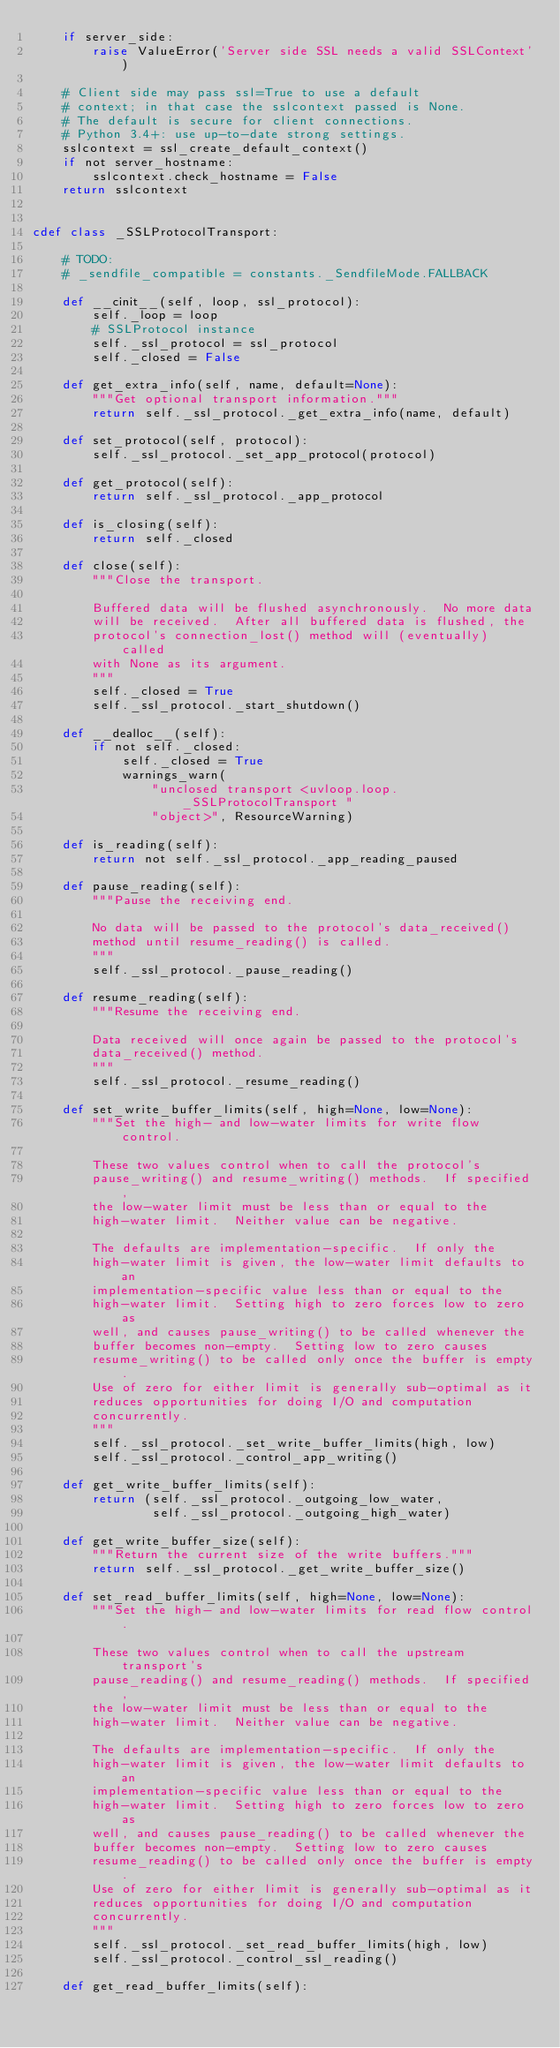Convert code to text. <code><loc_0><loc_0><loc_500><loc_500><_Cython_>    if server_side:
        raise ValueError('Server side SSL needs a valid SSLContext')

    # Client side may pass ssl=True to use a default
    # context; in that case the sslcontext passed is None.
    # The default is secure for client connections.
    # Python 3.4+: use up-to-date strong settings.
    sslcontext = ssl_create_default_context()
    if not server_hostname:
        sslcontext.check_hostname = False
    return sslcontext


cdef class _SSLProtocolTransport:

    # TODO:
    # _sendfile_compatible = constants._SendfileMode.FALLBACK

    def __cinit__(self, loop, ssl_protocol):
        self._loop = loop
        # SSLProtocol instance
        self._ssl_protocol = ssl_protocol
        self._closed = False

    def get_extra_info(self, name, default=None):
        """Get optional transport information."""
        return self._ssl_protocol._get_extra_info(name, default)

    def set_protocol(self, protocol):
        self._ssl_protocol._set_app_protocol(protocol)

    def get_protocol(self):
        return self._ssl_protocol._app_protocol

    def is_closing(self):
        return self._closed

    def close(self):
        """Close the transport.

        Buffered data will be flushed asynchronously.  No more data
        will be received.  After all buffered data is flushed, the
        protocol's connection_lost() method will (eventually) called
        with None as its argument.
        """
        self._closed = True
        self._ssl_protocol._start_shutdown()

    def __dealloc__(self):
        if not self._closed:
            self._closed = True
            warnings_warn(
                "unclosed transport <uvloop.loop._SSLProtocolTransport "
                "object>", ResourceWarning)

    def is_reading(self):
        return not self._ssl_protocol._app_reading_paused

    def pause_reading(self):
        """Pause the receiving end.

        No data will be passed to the protocol's data_received()
        method until resume_reading() is called.
        """
        self._ssl_protocol._pause_reading()

    def resume_reading(self):
        """Resume the receiving end.

        Data received will once again be passed to the protocol's
        data_received() method.
        """
        self._ssl_protocol._resume_reading()

    def set_write_buffer_limits(self, high=None, low=None):
        """Set the high- and low-water limits for write flow control.

        These two values control when to call the protocol's
        pause_writing() and resume_writing() methods.  If specified,
        the low-water limit must be less than or equal to the
        high-water limit.  Neither value can be negative.

        The defaults are implementation-specific.  If only the
        high-water limit is given, the low-water limit defaults to an
        implementation-specific value less than or equal to the
        high-water limit.  Setting high to zero forces low to zero as
        well, and causes pause_writing() to be called whenever the
        buffer becomes non-empty.  Setting low to zero causes
        resume_writing() to be called only once the buffer is empty.
        Use of zero for either limit is generally sub-optimal as it
        reduces opportunities for doing I/O and computation
        concurrently.
        """
        self._ssl_protocol._set_write_buffer_limits(high, low)
        self._ssl_protocol._control_app_writing()

    def get_write_buffer_limits(self):
        return (self._ssl_protocol._outgoing_low_water,
                self._ssl_protocol._outgoing_high_water)

    def get_write_buffer_size(self):
        """Return the current size of the write buffers."""
        return self._ssl_protocol._get_write_buffer_size()

    def set_read_buffer_limits(self, high=None, low=None):
        """Set the high- and low-water limits for read flow control.

        These two values control when to call the upstream transport's
        pause_reading() and resume_reading() methods.  If specified,
        the low-water limit must be less than or equal to the
        high-water limit.  Neither value can be negative.

        The defaults are implementation-specific.  If only the
        high-water limit is given, the low-water limit defaults to an
        implementation-specific value less than or equal to the
        high-water limit.  Setting high to zero forces low to zero as
        well, and causes pause_reading() to be called whenever the
        buffer becomes non-empty.  Setting low to zero causes
        resume_reading() to be called only once the buffer is empty.
        Use of zero for either limit is generally sub-optimal as it
        reduces opportunities for doing I/O and computation
        concurrently.
        """
        self._ssl_protocol._set_read_buffer_limits(high, low)
        self._ssl_protocol._control_ssl_reading()

    def get_read_buffer_limits(self):</code> 